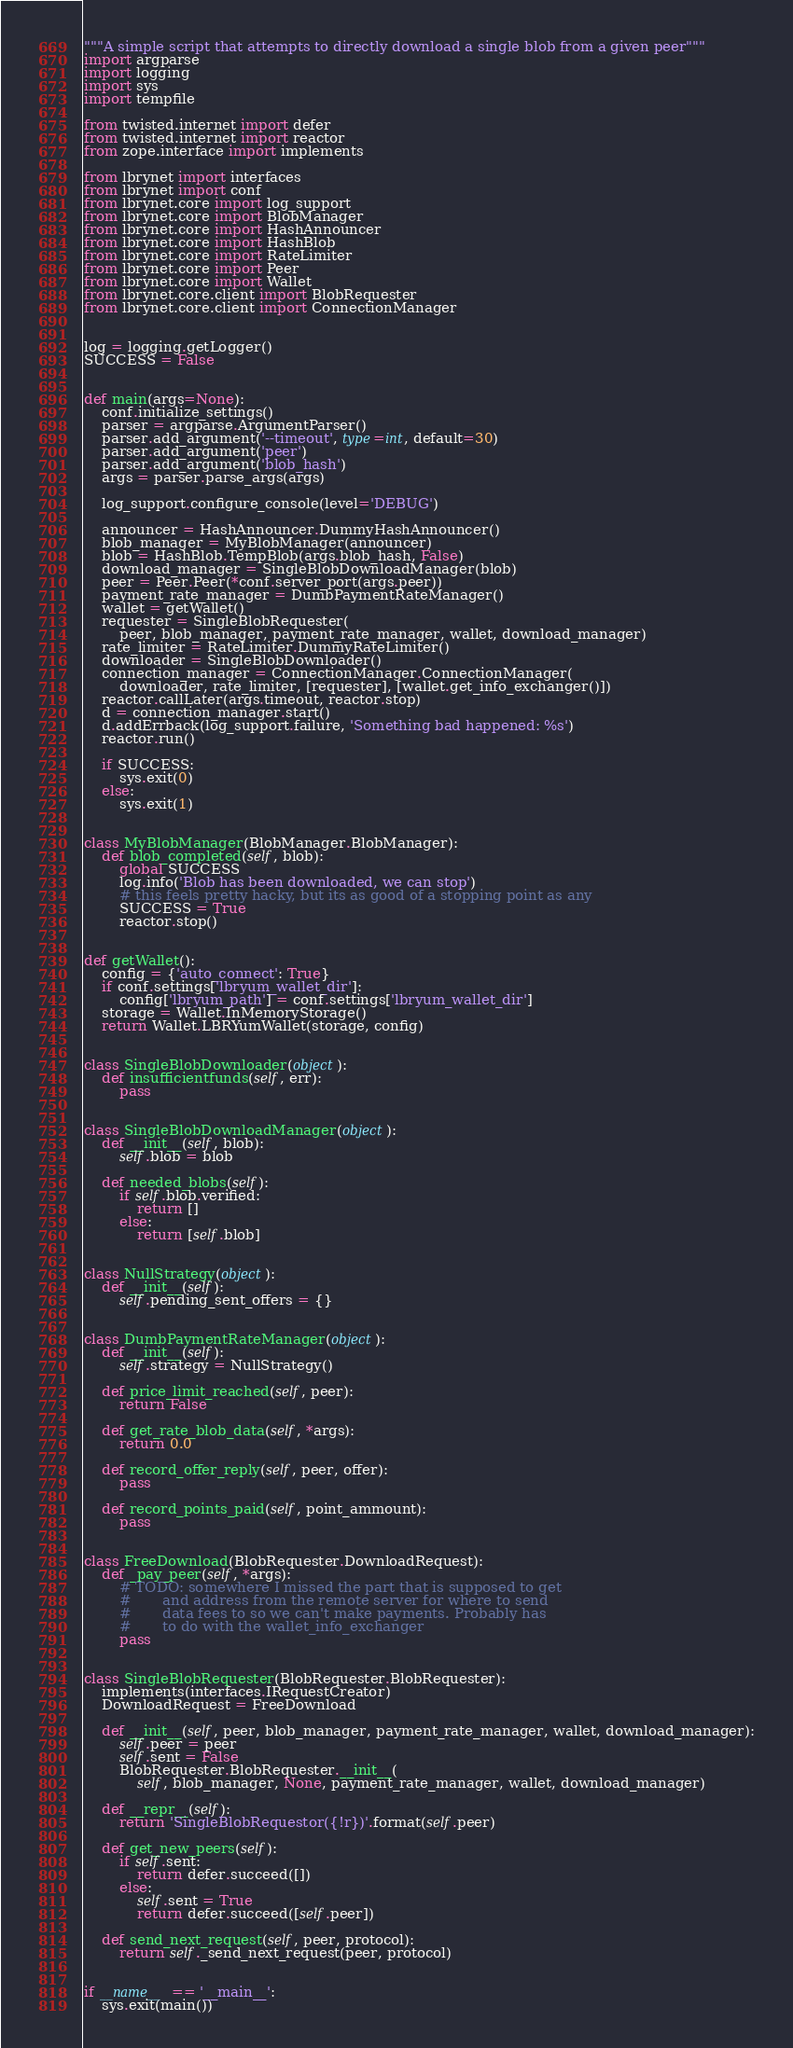<code> <loc_0><loc_0><loc_500><loc_500><_Python_>"""A simple script that attempts to directly download a single blob from a given peer"""
import argparse
import logging
import sys
import tempfile

from twisted.internet import defer
from twisted.internet import reactor
from zope.interface import implements

from lbrynet import interfaces
from lbrynet import conf
from lbrynet.core import log_support
from lbrynet.core import BlobManager
from lbrynet.core import HashAnnouncer
from lbrynet.core import HashBlob
from lbrynet.core import RateLimiter
from lbrynet.core import Peer
from lbrynet.core import Wallet
from lbrynet.core.client import BlobRequester
from lbrynet.core.client import ConnectionManager


log = logging.getLogger()
SUCCESS = False


def main(args=None):
    conf.initialize_settings()
    parser = argparse.ArgumentParser()
    parser.add_argument('--timeout', type=int, default=30)
    parser.add_argument('peer')
    parser.add_argument('blob_hash')
    args = parser.parse_args(args)

    log_support.configure_console(level='DEBUG')

    announcer = HashAnnouncer.DummyHashAnnouncer()
    blob_manager = MyBlobManager(announcer)
    blob = HashBlob.TempBlob(args.blob_hash, False)
    download_manager = SingleBlobDownloadManager(blob)
    peer = Peer.Peer(*conf.server_port(args.peer))
    payment_rate_manager = DumbPaymentRateManager()
    wallet = getWallet()
    requester = SingleBlobRequester(
        peer, blob_manager, payment_rate_manager, wallet, download_manager)
    rate_limiter = RateLimiter.DummyRateLimiter()
    downloader = SingleBlobDownloader()
    connection_manager = ConnectionManager.ConnectionManager(
        downloader, rate_limiter, [requester], [wallet.get_info_exchanger()])
    reactor.callLater(args.timeout, reactor.stop)
    d = connection_manager.start()
    d.addErrback(log_support.failure, 'Something bad happened: %s')
    reactor.run()

    if SUCCESS:
        sys.exit(0)
    else:
        sys.exit(1)


class MyBlobManager(BlobManager.BlobManager):
    def blob_completed(self, blob):
        global SUCCESS
        log.info('Blob has been downloaded, we can stop')
        # this feels pretty hacky, but its as good of a stopping point as any
        SUCCESS = True
        reactor.stop()


def getWallet():
    config = {'auto_connect': True}
    if conf.settings['lbryum_wallet_dir']:
        config['lbryum_path'] = conf.settings['lbryum_wallet_dir']
    storage = Wallet.InMemoryStorage()
    return Wallet.LBRYumWallet(storage, config)


class SingleBlobDownloader(object):
    def insufficientfunds(self, err):
        pass


class SingleBlobDownloadManager(object):
    def __init__(self, blob):
        self.blob = blob

    def needed_blobs(self):
        if self.blob.verified:
            return []
        else:
            return [self.blob]


class NullStrategy(object):
    def __init__(self):
        self.pending_sent_offers = {}


class DumbPaymentRateManager(object):
    def __init__(self):
        self.strategy = NullStrategy()

    def price_limit_reached(self, peer):
        return False

    def get_rate_blob_data(self, *args):
        return 0.0

    def record_offer_reply(self, peer, offer):
        pass

    def record_points_paid(self, point_ammount):
        pass


class FreeDownload(BlobRequester.DownloadRequest):
    def _pay_peer(self, *args):
        # TODO: somewhere I missed the part that is supposed to get
        #       and address from the remote server for where to send
        #       data fees to so we can't make payments. Probably has
        #       to do with the wallet_info_exchanger
        pass


class SingleBlobRequester(BlobRequester.BlobRequester):
    implements(interfaces.IRequestCreator)
    DownloadRequest = FreeDownload

    def __init__(self, peer, blob_manager, payment_rate_manager, wallet, download_manager):
        self.peer = peer
        self.sent = False
        BlobRequester.BlobRequester.__init__(
            self, blob_manager, None, payment_rate_manager, wallet, download_manager)

    def __repr__(self):
        return 'SingleBlobRequestor({!r})'.format(self.peer)

    def get_new_peers(self):
        if self.sent:
            return defer.succeed([])
        else:
            self.sent = True
            return defer.succeed([self.peer])

    def send_next_request(self, peer, protocol):
        return self._send_next_request(peer, protocol)


if __name__ == '__main__':
    sys.exit(main())
</code> 